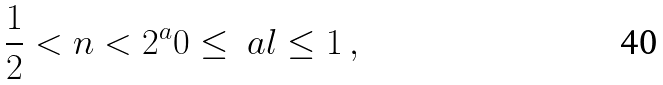Convert formula to latex. <formula><loc_0><loc_0><loc_500><loc_500>\frac { 1 } { 2 } < n < 2 ^ { a } 0 \leq \ a l \leq 1 \, ,</formula> 